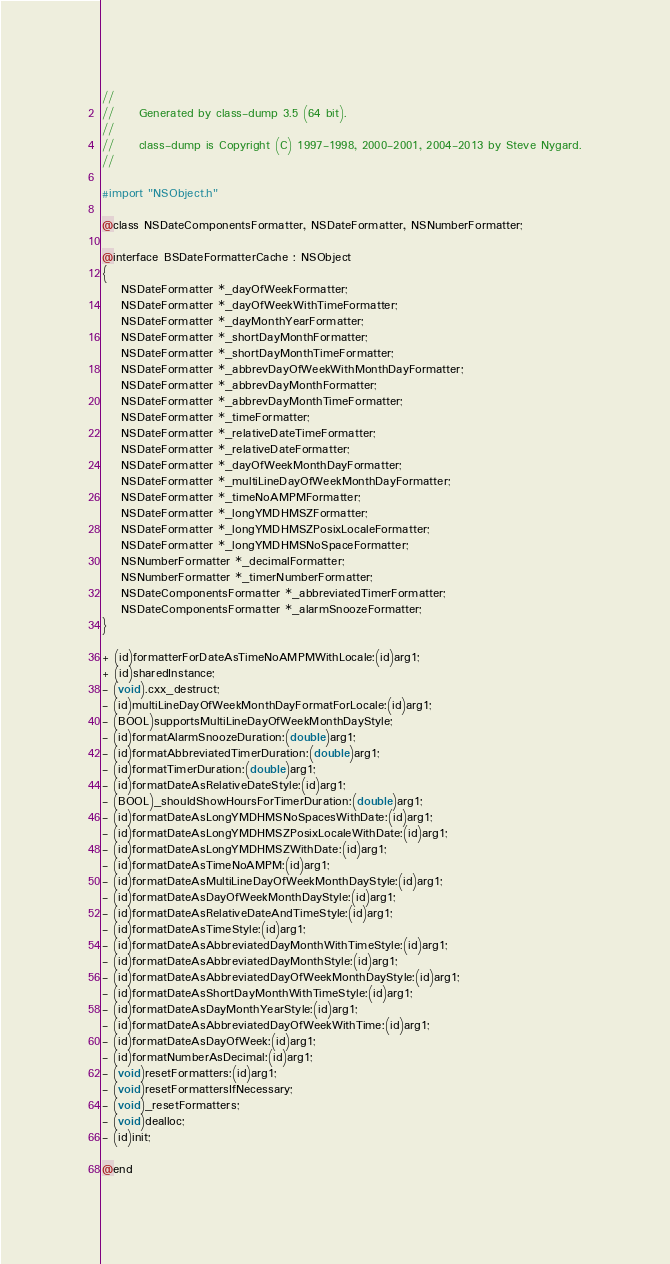Convert code to text. <code><loc_0><loc_0><loc_500><loc_500><_C_>//
//     Generated by class-dump 3.5 (64 bit).
//
//     class-dump is Copyright (C) 1997-1998, 2000-2001, 2004-2013 by Steve Nygard.
//

#import "NSObject.h"

@class NSDateComponentsFormatter, NSDateFormatter, NSNumberFormatter;

@interface BSDateFormatterCache : NSObject
{
    NSDateFormatter *_dayOfWeekFormatter;
    NSDateFormatter *_dayOfWeekWithTimeFormatter;
    NSDateFormatter *_dayMonthYearFormatter;
    NSDateFormatter *_shortDayMonthFormatter;
    NSDateFormatter *_shortDayMonthTimeFormatter;
    NSDateFormatter *_abbrevDayOfWeekWithMonthDayFormatter;
    NSDateFormatter *_abbrevDayMonthFormatter;
    NSDateFormatter *_abbrevDayMonthTimeFormatter;
    NSDateFormatter *_timeFormatter;
    NSDateFormatter *_relativeDateTimeFormatter;
    NSDateFormatter *_relativeDateFormatter;
    NSDateFormatter *_dayOfWeekMonthDayFormatter;
    NSDateFormatter *_multiLineDayOfWeekMonthDayFormatter;
    NSDateFormatter *_timeNoAMPMFormatter;
    NSDateFormatter *_longYMDHMSZFormatter;
    NSDateFormatter *_longYMDHMSZPosixLocaleFormatter;
    NSDateFormatter *_longYMDHMSNoSpaceFormatter;
    NSNumberFormatter *_decimalFormatter;
    NSNumberFormatter *_timerNumberFormatter;
    NSDateComponentsFormatter *_abbreviatedTimerFormatter;
    NSDateComponentsFormatter *_alarmSnoozeFormatter;
}

+ (id)formatterForDateAsTimeNoAMPMWithLocale:(id)arg1;
+ (id)sharedInstance;
- (void).cxx_destruct;
- (id)multiLineDayOfWeekMonthDayFormatForLocale:(id)arg1;
- (BOOL)supportsMultiLineDayOfWeekMonthDayStyle;
- (id)formatAlarmSnoozeDuration:(double)arg1;
- (id)formatAbbreviatedTimerDuration:(double)arg1;
- (id)formatTimerDuration:(double)arg1;
- (id)formatDateAsRelativeDateStyle:(id)arg1;
- (BOOL)_shouldShowHoursForTimerDuration:(double)arg1;
- (id)formatDateAsLongYMDHMSNoSpacesWithDate:(id)arg1;
- (id)formatDateAsLongYMDHMSZPosixLocaleWithDate:(id)arg1;
- (id)formatDateAsLongYMDHMSZWithDate:(id)arg1;
- (id)formatDateAsTimeNoAMPM:(id)arg1;
- (id)formatDateAsMultiLineDayOfWeekMonthDayStyle:(id)arg1;
- (id)formatDateAsDayOfWeekMonthDayStyle:(id)arg1;
- (id)formatDateAsRelativeDateAndTimeStyle:(id)arg1;
- (id)formatDateAsTimeStyle:(id)arg1;
- (id)formatDateAsAbbreviatedDayMonthWithTimeStyle:(id)arg1;
- (id)formatDateAsAbbreviatedDayMonthStyle:(id)arg1;
- (id)formatDateAsAbbreviatedDayOfWeekMonthDayStyle:(id)arg1;
- (id)formatDateAsShortDayMonthWithTimeStyle:(id)arg1;
- (id)formatDateAsDayMonthYearStyle:(id)arg1;
- (id)formatDateAsAbbreviatedDayOfWeekWithTime:(id)arg1;
- (id)formatDateAsDayOfWeek:(id)arg1;
- (id)formatNumberAsDecimal:(id)arg1;
- (void)resetFormatters:(id)arg1;
- (void)resetFormattersIfNecessary;
- (void)_resetFormatters;
- (void)dealloc;
- (id)init;

@end

</code> 